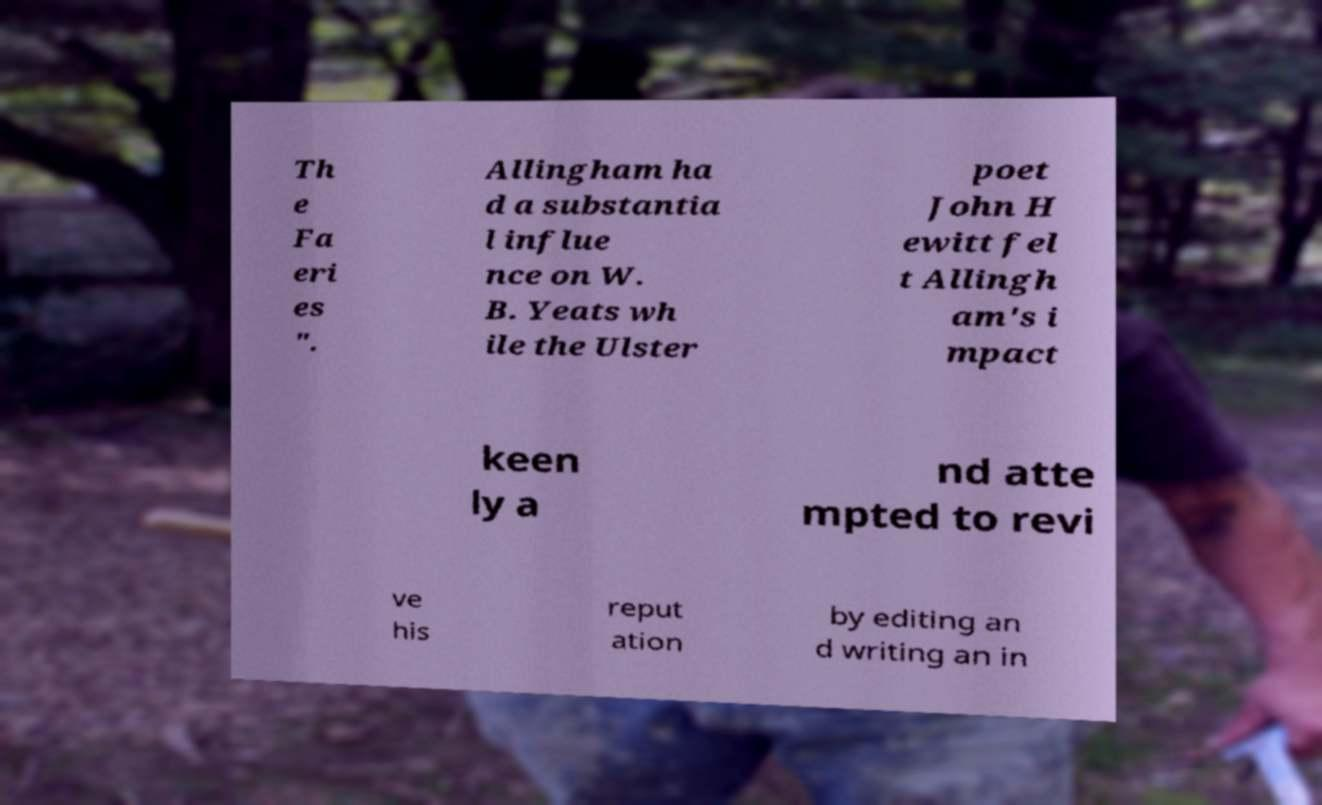There's text embedded in this image that I need extracted. Can you transcribe it verbatim? Th e Fa eri es ". Allingham ha d a substantia l influe nce on W. B. Yeats wh ile the Ulster poet John H ewitt fel t Allingh am's i mpact keen ly a nd atte mpted to revi ve his reput ation by editing an d writing an in 